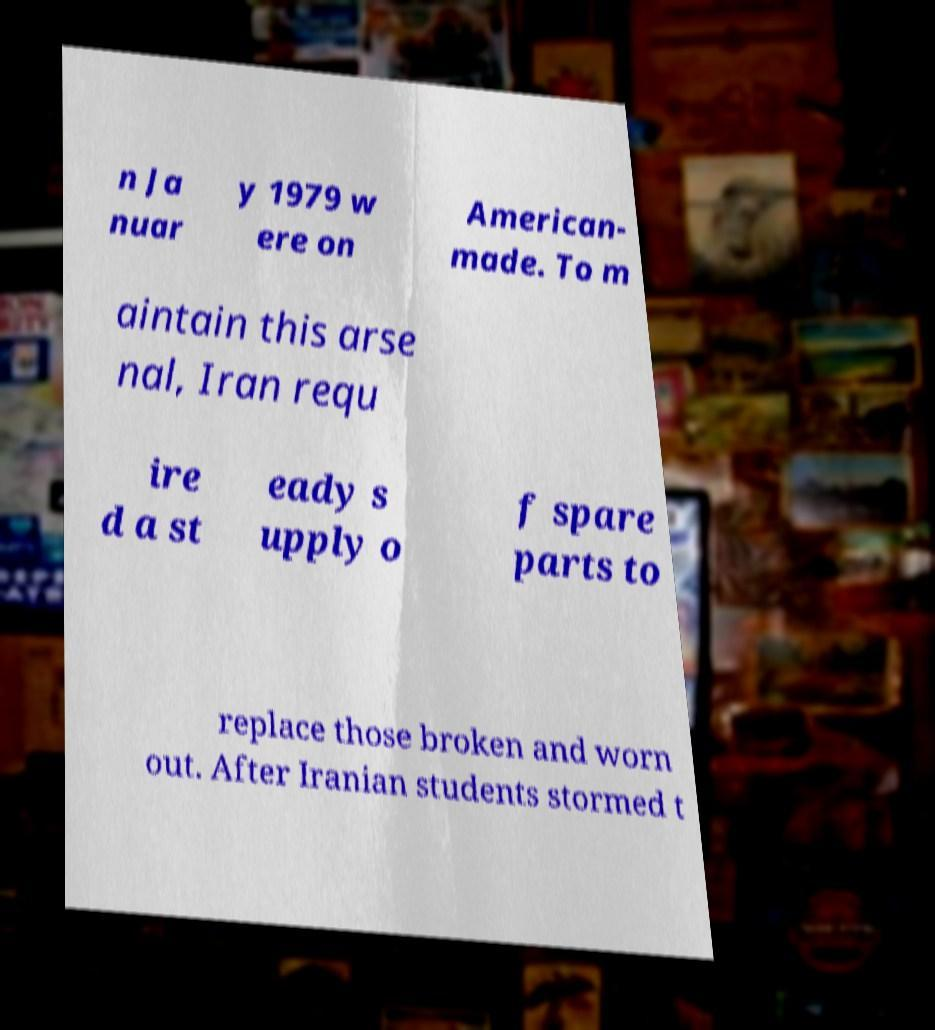There's text embedded in this image that I need extracted. Can you transcribe it verbatim? n Ja nuar y 1979 w ere on American- made. To m aintain this arse nal, Iran requ ire d a st eady s upply o f spare parts to replace those broken and worn out. After Iranian students stormed t 